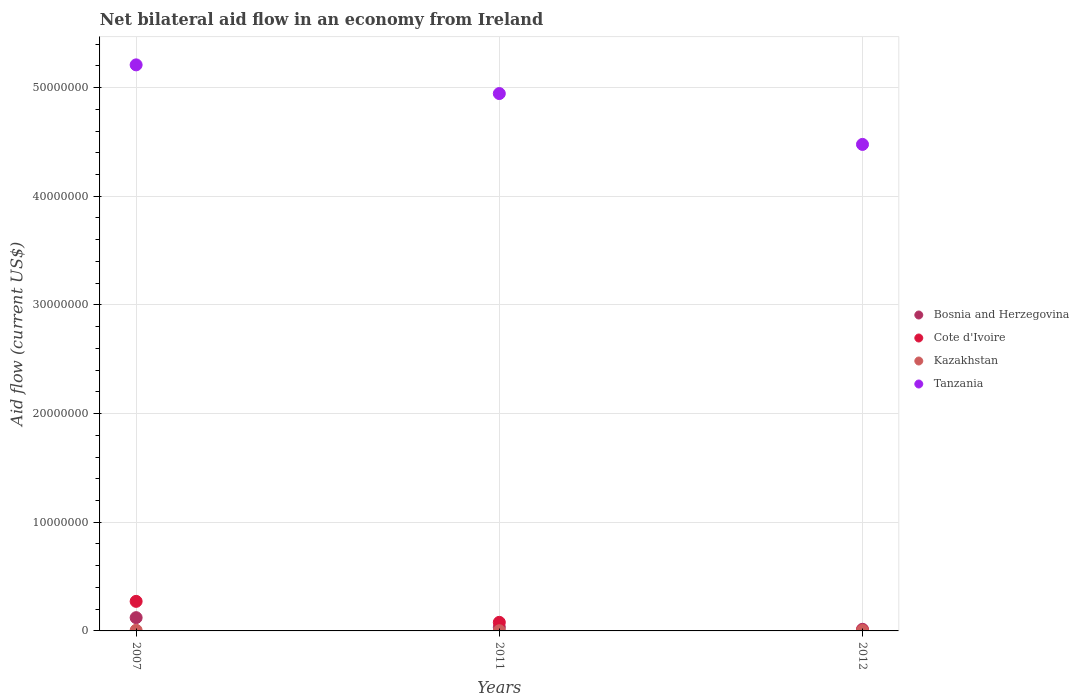How many different coloured dotlines are there?
Your answer should be very brief. 4. Is the number of dotlines equal to the number of legend labels?
Make the answer very short. Yes. What is the net bilateral aid flow in Kazakhstan in 2007?
Your response must be concise. 6.00e+04. Across all years, what is the maximum net bilateral aid flow in Tanzania?
Keep it short and to the point. 5.21e+07. Across all years, what is the minimum net bilateral aid flow in Bosnia and Herzegovina?
Offer a very short reply. 1.50e+05. What is the total net bilateral aid flow in Kazakhstan in the graph?
Keep it short and to the point. 1.20e+05. What is the difference between the net bilateral aid flow in Bosnia and Herzegovina in 2007 and that in 2012?
Make the answer very short. 1.07e+06. What is the difference between the net bilateral aid flow in Cote d'Ivoire in 2011 and the net bilateral aid flow in Kazakhstan in 2007?
Ensure brevity in your answer.  7.30e+05. What is the average net bilateral aid flow in Kazakhstan per year?
Make the answer very short. 4.00e+04. In how many years, is the net bilateral aid flow in Cote d'Ivoire greater than 18000000 US$?
Offer a terse response. 0. What is the ratio of the net bilateral aid flow in Cote d'Ivoire in 2007 to that in 2011?
Ensure brevity in your answer.  3.44. Is the net bilateral aid flow in Cote d'Ivoire in 2007 less than that in 2012?
Provide a short and direct response. No. What is the difference between the highest and the second highest net bilateral aid flow in Kazakhstan?
Your answer should be very brief. 2.00e+04. What is the difference between the highest and the lowest net bilateral aid flow in Tanzania?
Your response must be concise. 7.32e+06. Is the sum of the net bilateral aid flow in Bosnia and Herzegovina in 2011 and 2012 greater than the maximum net bilateral aid flow in Cote d'Ivoire across all years?
Your response must be concise. No. Is the net bilateral aid flow in Bosnia and Herzegovina strictly less than the net bilateral aid flow in Kazakhstan over the years?
Your response must be concise. No. How many dotlines are there?
Make the answer very short. 4. How many years are there in the graph?
Your response must be concise. 3. What is the difference between two consecutive major ticks on the Y-axis?
Make the answer very short. 1.00e+07. Does the graph contain any zero values?
Provide a short and direct response. No. Does the graph contain grids?
Provide a short and direct response. Yes. How are the legend labels stacked?
Your answer should be very brief. Vertical. What is the title of the graph?
Provide a short and direct response. Net bilateral aid flow in an economy from Ireland. What is the label or title of the X-axis?
Provide a short and direct response. Years. What is the Aid flow (current US$) in Bosnia and Herzegovina in 2007?
Provide a succinct answer. 1.22e+06. What is the Aid flow (current US$) of Cote d'Ivoire in 2007?
Offer a very short reply. 2.72e+06. What is the Aid flow (current US$) of Kazakhstan in 2007?
Ensure brevity in your answer.  6.00e+04. What is the Aid flow (current US$) of Tanzania in 2007?
Give a very brief answer. 5.21e+07. What is the Aid flow (current US$) of Bosnia and Herzegovina in 2011?
Keep it short and to the point. 3.40e+05. What is the Aid flow (current US$) of Cote d'Ivoire in 2011?
Offer a very short reply. 7.90e+05. What is the Aid flow (current US$) of Kazakhstan in 2011?
Ensure brevity in your answer.  2.00e+04. What is the Aid flow (current US$) in Tanzania in 2011?
Give a very brief answer. 4.94e+07. What is the Aid flow (current US$) in Kazakhstan in 2012?
Keep it short and to the point. 4.00e+04. What is the Aid flow (current US$) in Tanzania in 2012?
Offer a terse response. 4.48e+07. Across all years, what is the maximum Aid flow (current US$) in Bosnia and Herzegovina?
Your response must be concise. 1.22e+06. Across all years, what is the maximum Aid flow (current US$) in Cote d'Ivoire?
Give a very brief answer. 2.72e+06. Across all years, what is the maximum Aid flow (current US$) in Tanzania?
Your response must be concise. 5.21e+07. Across all years, what is the minimum Aid flow (current US$) in Bosnia and Herzegovina?
Provide a succinct answer. 1.50e+05. Across all years, what is the minimum Aid flow (current US$) in Cote d'Ivoire?
Provide a short and direct response. 5.00e+04. Across all years, what is the minimum Aid flow (current US$) in Tanzania?
Provide a short and direct response. 4.48e+07. What is the total Aid flow (current US$) of Bosnia and Herzegovina in the graph?
Your response must be concise. 1.71e+06. What is the total Aid flow (current US$) of Cote d'Ivoire in the graph?
Give a very brief answer. 3.56e+06. What is the total Aid flow (current US$) of Kazakhstan in the graph?
Offer a terse response. 1.20e+05. What is the total Aid flow (current US$) in Tanzania in the graph?
Your answer should be very brief. 1.46e+08. What is the difference between the Aid flow (current US$) in Bosnia and Herzegovina in 2007 and that in 2011?
Give a very brief answer. 8.80e+05. What is the difference between the Aid flow (current US$) of Cote d'Ivoire in 2007 and that in 2011?
Offer a very short reply. 1.93e+06. What is the difference between the Aid flow (current US$) in Tanzania in 2007 and that in 2011?
Keep it short and to the point. 2.64e+06. What is the difference between the Aid flow (current US$) of Bosnia and Herzegovina in 2007 and that in 2012?
Provide a succinct answer. 1.07e+06. What is the difference between the Aid flow (current US$) of Cote d'Ivoire in 2007 and that in 2012?
Your response must be concise. 2.67e+06. What is the difference between the Aid flow (current US$) in Tanzania in 2007 and that in 2012?
Offer a very short reply. 7.32e+06. What is the difference between the Aid flow (current US$) in Bosnia and Herzegovina in 2011 and that in 2012?
Offer a terse response. 1.90e+05. What is the difference between the Aid flow (current US$) of Cote d'Ivoire in 2011 and that in 2012?
Give a very brief answer. 7.40e+05. What is the difference between the Aid flow (current US$) of Kazakhstan in 2011 and that in 2012?
Offer a terse response. -2.00e+04. What is the difference between the Aid flow (current US$) in Tanzania in 2011 and that in 2012?
Your answer should be very brief. 4.68e+06. What is the difference between the Aid flow (current US$) in Bosnia and Herzegovina in 2007 and the Aid flow (current US$) in Kazakhstan in 2011?
Make the answer very short. 1.20e+06. What is the difference between the Aid flow (current US$) of Bosnia and Herzegovina in 2007 and the Aid flow (current US$) of Tanzania in 2011?
Ensure brevity in your answer.  -4.82e+07. What is the difference between the Aid flow (current US$) in Cote d'Ivoire in 2007 and the Aid flow (current US$) in Kazakhstan in 2011?
Make the answer very short. 2.70e+06. What is the difference between the Aid flow (current US$) in Cote d'Ivoire in 2007 and the Aid flow (current US$) in Tanzania in 2011?
Give a very brief answer. -4.67e+07. What is the difference between the Aid flow (current US$) in Kazakhstan in 2007 and the Aid flow (current US$) in Tanzania in 2011?
Your answer should be compact. -4.94e+07. What is the difference between the Aid flow (current US$) in Bosnia and Herzegovina in 2007 and the Aid flow (current US$) in Cote d'Ivoire in 2012?
Offer a terse response. 1.17e+06. What is the difference between the Aid flow (current US$) of Bosnia and Herzegovina in 2007 and the Aid flow (current US$) of Kazakhstan in 2012?
Your answer should be compact. 1.18e+06. What is the difference between the Aid flow (current US$) of Bosnia and Herzegovina in 2007 and the Aid flow (current US$) of Tanzania in 2012?
Give a very brief answer. -4.36e+07. What is the difference between the Aid flow (current US$) of Cote d'Ivoire in 2007 and the Aid flow (current US$) of Kazakhstan in 2012?
Ensure brevity in your answer.  2.68e+06. What is the difference between the Aid flow (current US$) in Cote d'Ivoire in 2007 and the Aid flow (current US$) in Tanzania in 2012?
Your response must be concise. -4.20e+07. What is the difference between the Aid flow (current US$) in Kazakhstan in 2007 and the Aid flow (current US$) in Tanzania in 2012?
Your response must be concise. -4.47e+07. What is the difference between the Aid flow (current US$) of Bosnia and Herzegovina in 2011 and the Aid flow (current US$) of Kazakhstan in 2012?
Offer a very short reply. 3.00e+05. What is the difference between the Aid flow (current US$) of Bosnia and Herzegovina in 2011 and the Aid flow (current US$) of Tanzania in 2012?
Offer a very short reply. -4.44e+07. What is the difference between the Aid flow (current US$) in Cote d'Ivoire in 2011 and the Aid flow (current US$) in Kazakhstan in 2012?
Your answer should be very brief. 7.50e+05. What is the difference between the Aid flow (current US$) of Cote d'Ivoire in 2011 and the Aid flow (current US$) of Tanzania in 2012?
Make the answer very short. -4.40e+07. What is the difference between the Aid flow (current US$) in Kazakhstan in 2011 and the Aid flow (current US$) in Tanzania in 2012?
Give a very brief answer. -4.48e+07. What is the average Aid flow (current US$) of Bosnia and Herzegovina per year?
Your answer should be compact. 5.70e+05. What is the average Aid flow (current US$) in Cote d'Ivoire per year?
Make the answer very short. 1.19e+06. What is the average Aid flow (current US$) in Kazakhstan per year?
Offer a terse response. 4.00e+04. What is the average Aid flow (current US$) of Tanzania per year?
Ensure brevity in your answer.  4.88e+07. In the year 2007, what is the difference between the Aid flow (current US$) in Bosnia and Herzegovina and Aid flow (current US$) in Cote d'Ivoire?
Provide a short and direct response. -1.50e+06. In the year 2007, what is the difference between the Aid flow (current US$) of Bosnia and Herzegovina and Aid flow (current US$) of Kazakhstan?
Offer a very short reply. 1.16e+06. In the year 2007, what is the difference between the Aid flow (current US$) of Bosnia and Herzegovina and Aid flow (current US$) of Tanzania?
Offer a very short reply. -5.09e+07. In the year 2007, what is the difference between the Aid flow (current US$) of Cote d'Ivoire and Aid flow (current US$) of Kazakhstan?
Give a very brief answer. 2.66e+06. In the year 2007, what is the difference between the Aid flow (current US$) of Cote d'Ivoire and Aid flow (current US$) of Tanzania?
Make the answer very short. -4.94e+07. In the year 2007, what is the difference between the Aid flow (current US$) in Kazakhstan and Aid flow (current US$) in Tanzania?
Offer a terse response. -5.20e+07. In the year 2011, what is the difference between the Aid flow (current US$) of Bosnia and Herzegovina and Aid flow (current US$) of Cote d'Ivoire?
Provide a short and direct response. -4.50e+05. In the year 2011, what is the difference between the Aid flow (current US$) in Bosnia and Herzegovina and Aid flow (current US$) in Kazakhstan?
Give a very brief answer. 3.20e+05. In the year 2011, what is the difference between the Aid flow (current US$) of Bosnia and Herzegovina and Aid flow (current US$) of Tanzania?
Your answer should be compact. -4.91e+07. In the year 2011, what is the difference between the Aid flow (current US$) in Cote d'Ivoire and Aid flow (current US$) in Kazakhstan?
Provide a short and direct response. 7.70e+05. In the year 2011, what is the difference between the Aid flow (current US$) in Cote d'Ivoire and Aid flow (current US$) in Tanzania?
Make the answer very short. -4.87e+07. In the year 2011, what is the difference between the Aid flow (current US$) in Kazakhstan and Aid flow (current US$) in Tanzania?
Make the answer very short. -4.94e+07. In the year 2012, what is the difference between the Aid flow (current US$) in Bosnia and Herzegovina and Aid flow (current US$) in Kazakhstan?
Provide a succinct answer. 1.10e+05. In the year 2012, what is the difference between the Aid flow (current US$) in Bosnia and Herzegovina and Aid flow (current US$) in Tanzania?
Give a very brief answer. -4.46e+07. In the year 2012, what is the difference between the Aid flow (current US$) in Cote d'Ivoire and Aid flow (current US$) in Tanzania?
Your response must be concise. -4.47e+07. In the year 2012, what is the difference between the Aid flow (current US$) of Kazakhstan and Aid flow (current US$) of Tanzania?
Offer a very short reply. -4.47e+07. What is the ratio of the Aid flow (current US$) in Bosnia and Herzegovina in 2007 to that in 2011?
Your answer should be compact. 3.59. What is the ratio of the Aid flow (current US$) in Cote d'Ivoire in 2007 to that in 2011?
Give a very brief answer. 3.44. What is the ratio of the Aid flow (current US$) of Kazakhstan in 2007 to that in 2011?
Offer a very short reply. 3. What is the ratio of the Aid flow (current US$) in Tanzania in 2007 to that in 2011?
Provide a short and direct response. 1.05. What is the ratio of the Aid flow (current US$) in Bosnia and Herzegovina in 2007 to that in 2012?
Provide a short and direct response. 8.13. What is the ratio of the Aid flow (current US$) in Cote d'Ivoire in 2007 to that in 2012?
Your answer should be very brief. 54.4. What is the ratio of the Aid flow (current US$) in Kazakhstan in 2007 to that in 2012?
Ensure brevity in your answer.  1.5. What is the ratio of the Aid flow (current US$) in Tanzania in 2007 to that in 2012?
Provide a short and direct response. 1.16. What is the ratio of the Aid flow (current US$) of Bosnia and Herzegovina in 2011 to that in 2012?
Your response must be concise. 2.27. What is the ratio of the Aid flow (current US$) in Tanzania in 2011 to that in 2012?
Your response must be concise. 1.1. What is the difference between the highest and the second highest Aid flow (current US$) in Bosnia and Herzegovina?
Make the answer very short. 8.80e+05. What is the difference between the highest and the second highest Aid flow (current US$) in Cote d'Ivoire?
Your answer should be very brief. 1.93e+06. What is the difference between the highest and the second highest Aid flow (current US$) in Kazakhstan?
Give a very brief answer. 2.00e+04. What is the difference between the highest and the second highest Aid flow (current US$) of Tanzania?
Your answer should be compact. 2.64e+06. What is the difference between the highest and the lowest Aid flow (current US$) of Bosnia and Herzegovina?
Provide a short and direct response. 1.07e+06. What is the difference between the highest and the lowest Aid flow (current US$) of Cote d'Ivoire?
Provide a succinct answer. 2.67e+06. What is the difference between the highest and the lowest Aid flow (current US$) in Tanzania?
Your response must be concise. 7.32e+06. 